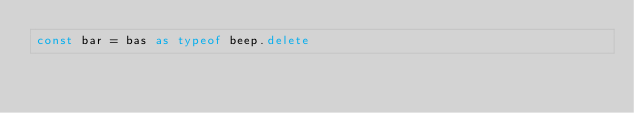<code> <loc_0><loc_0><loc_500><loc_500><_TypeScript_>const bar = bas as typeof beep.delete
</code> 